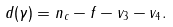<formula> <loc_0><loc_0><loc_500><loc_500>d ( \gamma ) = n _ { c } - f - v _ { 3 } - v _ { 4 } .</formula> 